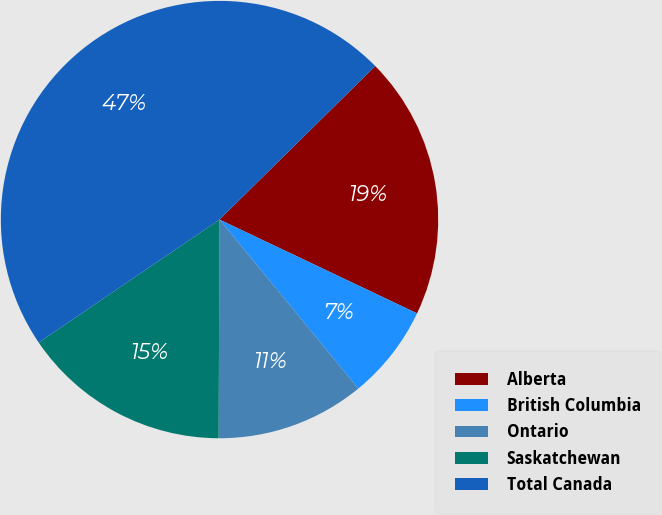<chart> <loc_0><loc_0><loc_500><loc_500><pie_chart><fcel>Alberta<fcel>British Columbia<fcel>Ontario<fcel>Saskatchewan<fcel>Total Canada<nl><fcel>19.44%<fcel>7.0%<fcel>11.01%<fcel>15.43%<fcel>47.12%<nl></chart> 